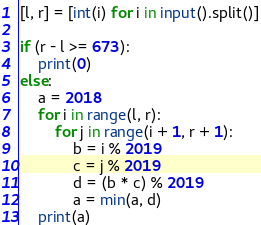Convert code to text. <code><loc_0><loc_0><loc_500><loc_500><_Python_>[l, r] = [int(i) for i in input().split()]

if (r - l >= 673):
    print(0)
else:
    a = 2018
    for i in range(l, r):
        for j in range(i + 1, r + 1):
            b = i % 2019
            c = j % 2019
            d = (b * c) % 2019
            a = min(a, d)
    print(a)
</code> 